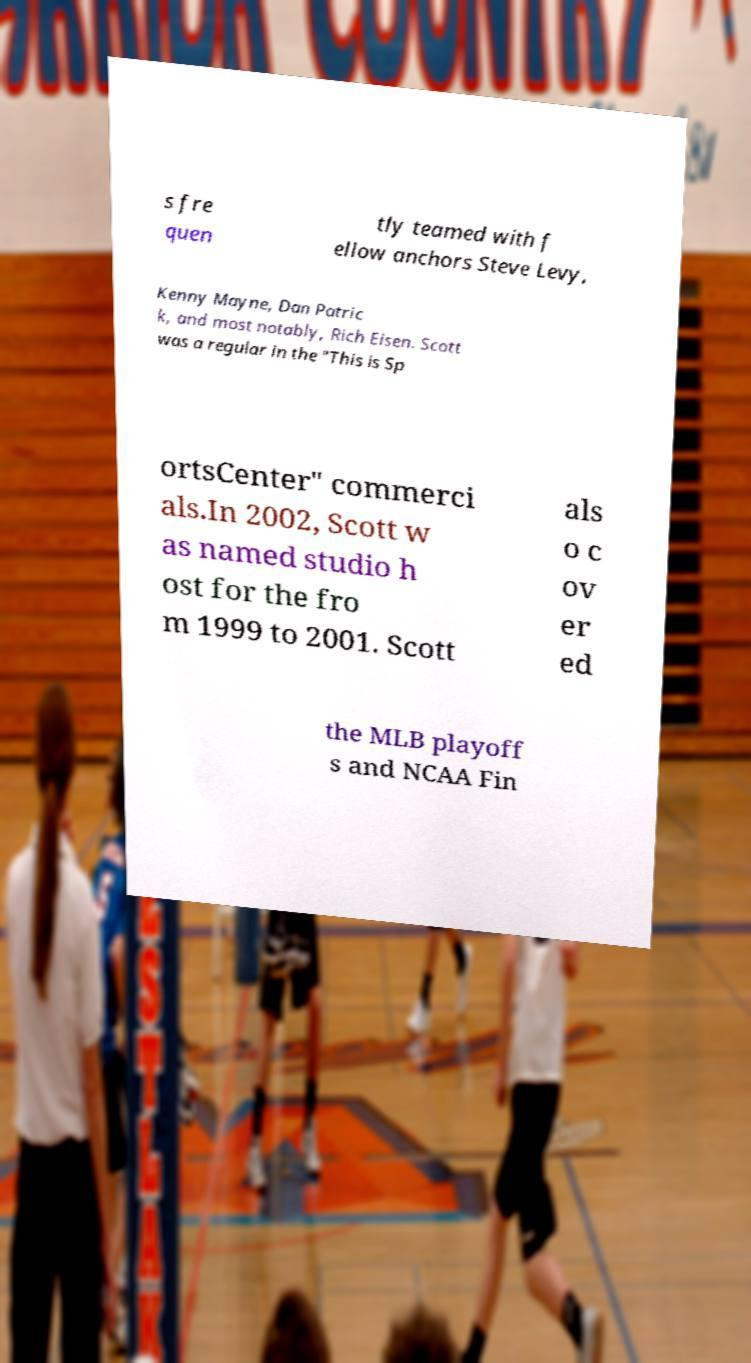Please read and relay the text visible in this image. What does it say? s fre quen tly teamed with f ellow anchors Steve Levy, Kenny Mayne, Dan Patric k, and most notably, Rich Eisen. Scott was a regular in the "This is Sp ortsCenter" commerci als.In 2002, Scott w as named studio h ost for the fro m 1999 to 2001. Scott als o c ov er ed the MLB playoff s and NCAA Fin 